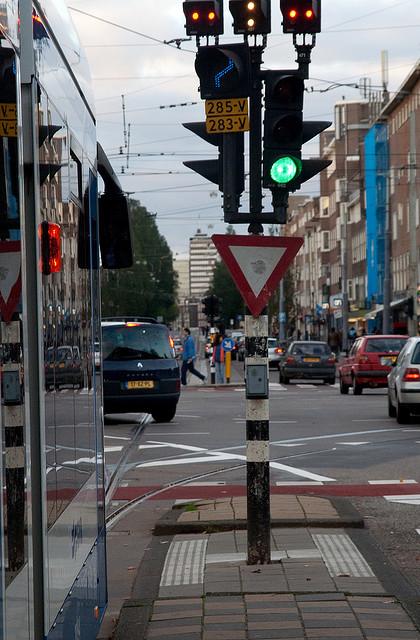Is there a no turning left sign?
Answer briefly. No. Are there any pedestrians?
Give a very brief answer. Yes. What shape is the sign below the traffic sign?
Be succinct. Triangle. Do the cars have yellow license plates?
Keep it brief. Yes. Is this a bike friendly street?
Concise answer only. No. 